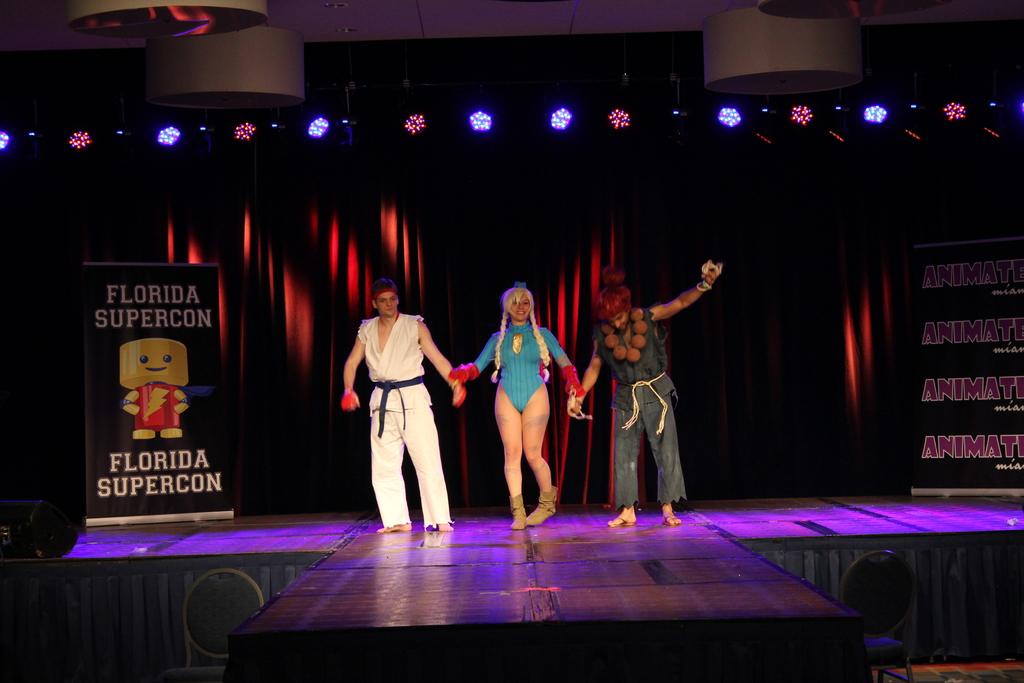In what event is this photo taken?
Provide a short and direct response. Florida supercon. What state was it?
Your answer should be very brief. Florida. 